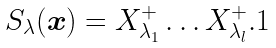<formula> <loc_0><loc_0><loc_500><loc_500>S _ { \lambda } ( { \boldsymbol x } ) = X ^ { + } _ { \lambda _ { 1 } } \dots X ^ { + } _ { \lambda _ { l } } . 1</formula> 